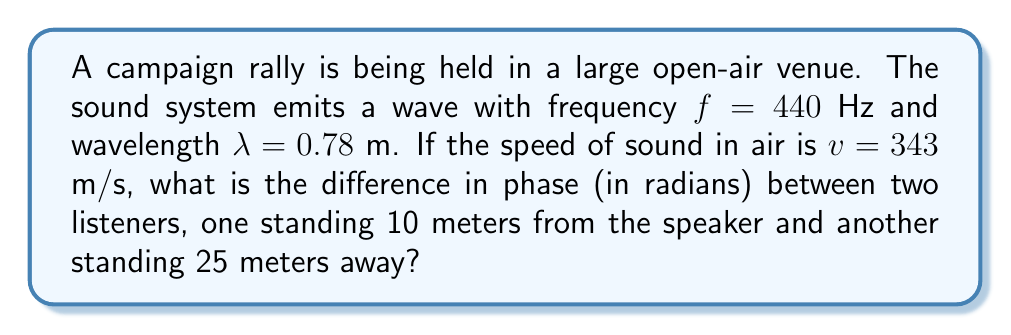Help me with this question. To solve this problem, we'll follow these steps:

1) First, recall the wave equation for a simple harmonic wave:

   $$ y(x,t) = A \sin(kx - \omega t + \phi) $$

   where $k$ is the wave number and $\omega$ is the angular frequency.

2) The wave number $k$ is given by:

   $$ k = \frac{2\pi}{\lambda} = \frac{2\pi}{0.78} \approx 8.05 \text{ rad/m} $$

3) The phase of the wave at a distance $x$ from the source (ignoring the time component) is:

   $$ \phi(x) = kx $$

4) For the listener at 10 meters:

   $$ \phi(10) = 8.05 \cdot 10 = 80.5 \text{ rad} $$

5) For the listener at 25 meters:

   $$ \phi(25) = 8.05 \cdot 25 = 201.25 \text{ rad} $$

6) The difference in phase is:

   $$ \Delta \phi = \phi(25) - \phi(10) = 201.25 - 80.5 = 120.75 \text{ rad} $$

7) We can express this in terms of $2\pi$ to simplify:

   $$ \Delta \phi = 120.75 \text{ rad} = 19.22 \cdot 2\pi \text{ rad} $$

8) The fractional part represents the actual phase difference:

   $$ \Delta \phi = 0.22 \cdot 2\pi \text{ rad} = 1.38 \text{ rad} $$
Answer: 1.38 rad 